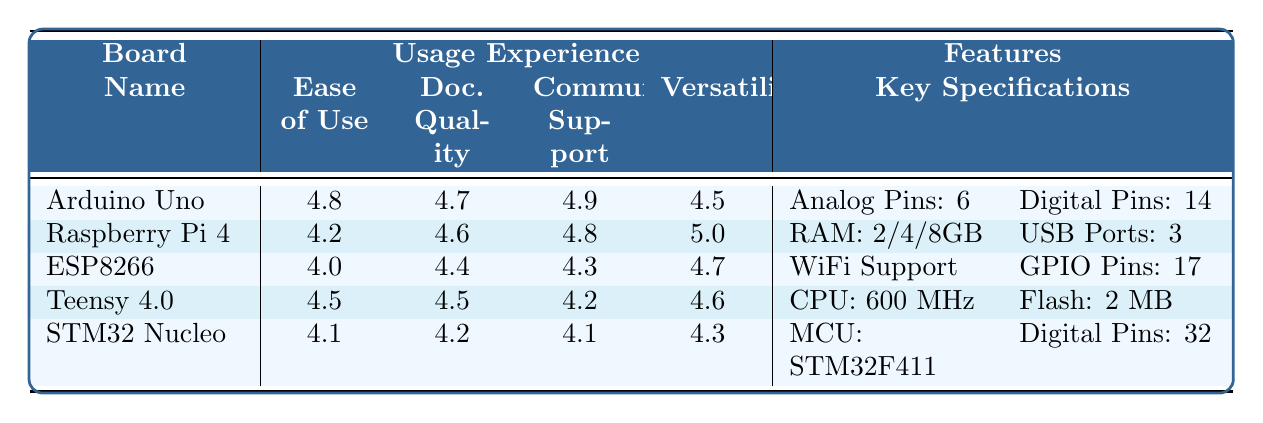What is the ease of use rating for the Arduino Uno? The ease of use rating for the Arduino Uno is listed in the table under the "Usage Experience" section, specifically in the "Ease of Use" column, which shows a value of 4.8.
Answer: 4.8 Which board has the highest community support rating? Reviewing the "Community Support" column for all boards, the Arduino Uno has a community support rating of 4.9, which is the highest compared to others.
Answer: Arduino Uno What is the average versatility rating of all boards listed? To find the average versatility rating, add the versatility scores (4.5, 5.0, 4.7, 4.6, 4.3) resulting in a total of 23.1. Then divide by the number of boards (5), giving an average of 23.1 / 5 = 4.62.
Answer: 4.62 Does the ESP8266 support WiFi? The table specifies that the ESP8266 includes a "WiFi Support" feature, indicating that it does support WiFi connectivity.
Answer: Yes Which board has the most analog pins? The table shows that the Arduino Uno has 6 analog pins, while other boards either have fewer or do not specify analog pins. Therefore, it has the highest count in this category.
Answer: Arduino Uno What is the combined number of digital pins and PWM pins for the Teensy 4.0? The Teensy 4.0 has 12 PWM channels and 32 digital pins, adding these two values provides a total of 12 + 32 = 44.
Answer: 44 Which board would you recommend for IoT projects based on the table, and why? The ESP8266 is specifically noted for its ease of setup for IoT projects in user comments. Additionally, it includes WiFi support, making it an excellent choice for such applications.
Answer: ESP8266 Is there a board that has 32 digital pins? In the "Features" section, the STM32 Nucleo is identified as having 32 digital pins, confirming that there is indeed such a board.
Answer: Yes What is the difference in ease of use between the Raspberry Pi 4 and the STM32 Nucleo? The Brooklyn Raspberry Pi 4 has an ease of use rating of 4.2, while the STM32 Nucleo has an ease of use rating of 4.1. Calculating the difference gives 4.2 - 4.1 = 0.1.
Answer: 0.1 Which board is noted for being extremely efficient for complex tasks? The Teensy 4.0 is highlighted in the user comments for its speed and efficiency when handling complex tasks.
Answer: Teensy 4.0 